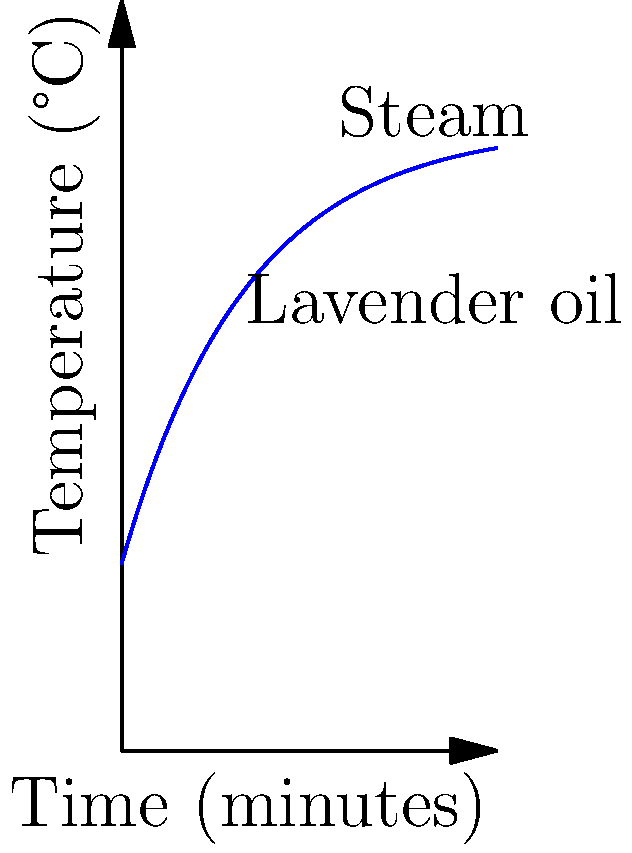In a small-scale essential oil distillation unit for lavender processing, the temperature of the steam rises according to the equation $T(t) = 100 - 70e^{-0.05t}$, where $T$ is the temperature in °C and $t$ is the time in minutes. At what time does the steam reach 90°C? To find the time when the steam reaches 90°C, we need to solve the equation:

1) Set up the equation:
   $90 = 100 - 70e^{-0.05t}$

2) Subtract 100 from both sides:
   $-10 = -70e^{-0.05t}$

3) Divide both sides by -70:
   $\frac{1}{7} = e^{-0.05t}$

4) Take the natural logarithm of both sides:
   $\ln(\frac{1}{7}) = -0.05t$

5) Multiply both sides by -20:
   $-20\ln(\frac{1}{7}) = t$

6) Calculate the result:
   $t \approx 38.47$ minutes

Therefore, the steam reaches 90°C after approximately 38.47 minutes.
Answer: 38.47 minutes 